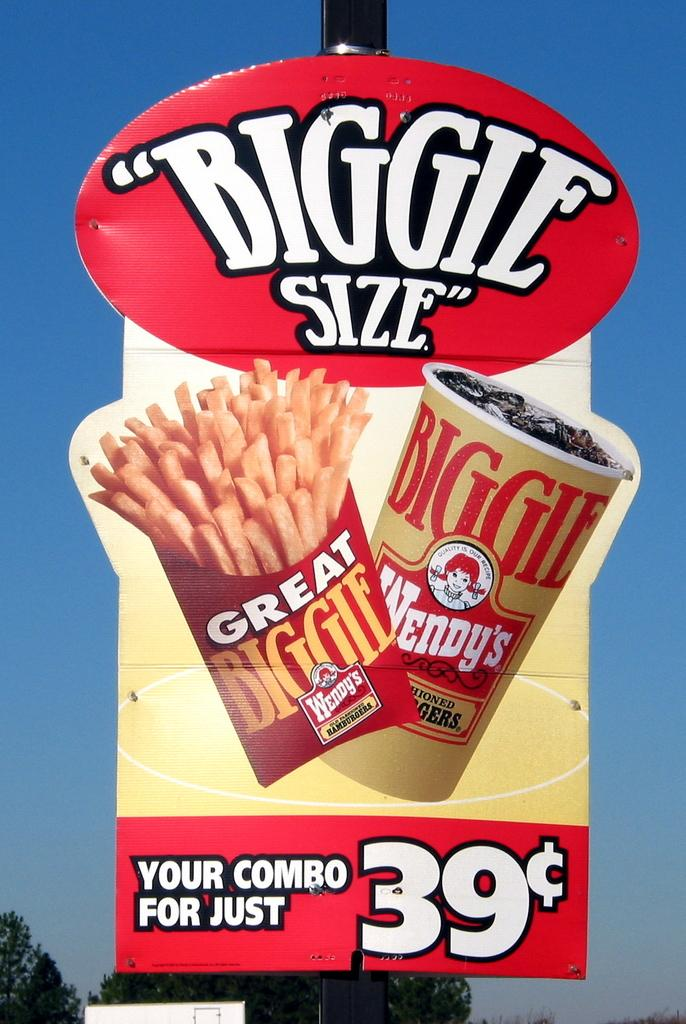What is the main object in the image? There is a board in the image. What can be seen on the board? A: There are pictures of food and text on the board. What is visible in the background of the image? There are trees in the background of the image. What is visible at the top of the image? The sky is visible at the top of the image. Where is the minister sitting in the image? There is no minister present in the image. Can you tell me how many knees are visible in the image? There are no knees visible in the image. What type of park can be seen in the background of the image? There is no park present in the image; it features trees in the background. 